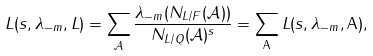<formula> <loc_0><loc_0><loc_500><loc_500>L ( s , \lambda _ { - m } , L ) = \sum _ { \mathcal { A } } \frac { \lambda _ { - m } ( N _ { L / F } ( { \mathcal { A } } ) ) } { N _ { L / Q } ( { \mathcal { A } } ) ^ { s } } = \sum _ { \mathsf A } L ( s , \lambda _ { - m } , { \mathsf A } ) ,</formula> 